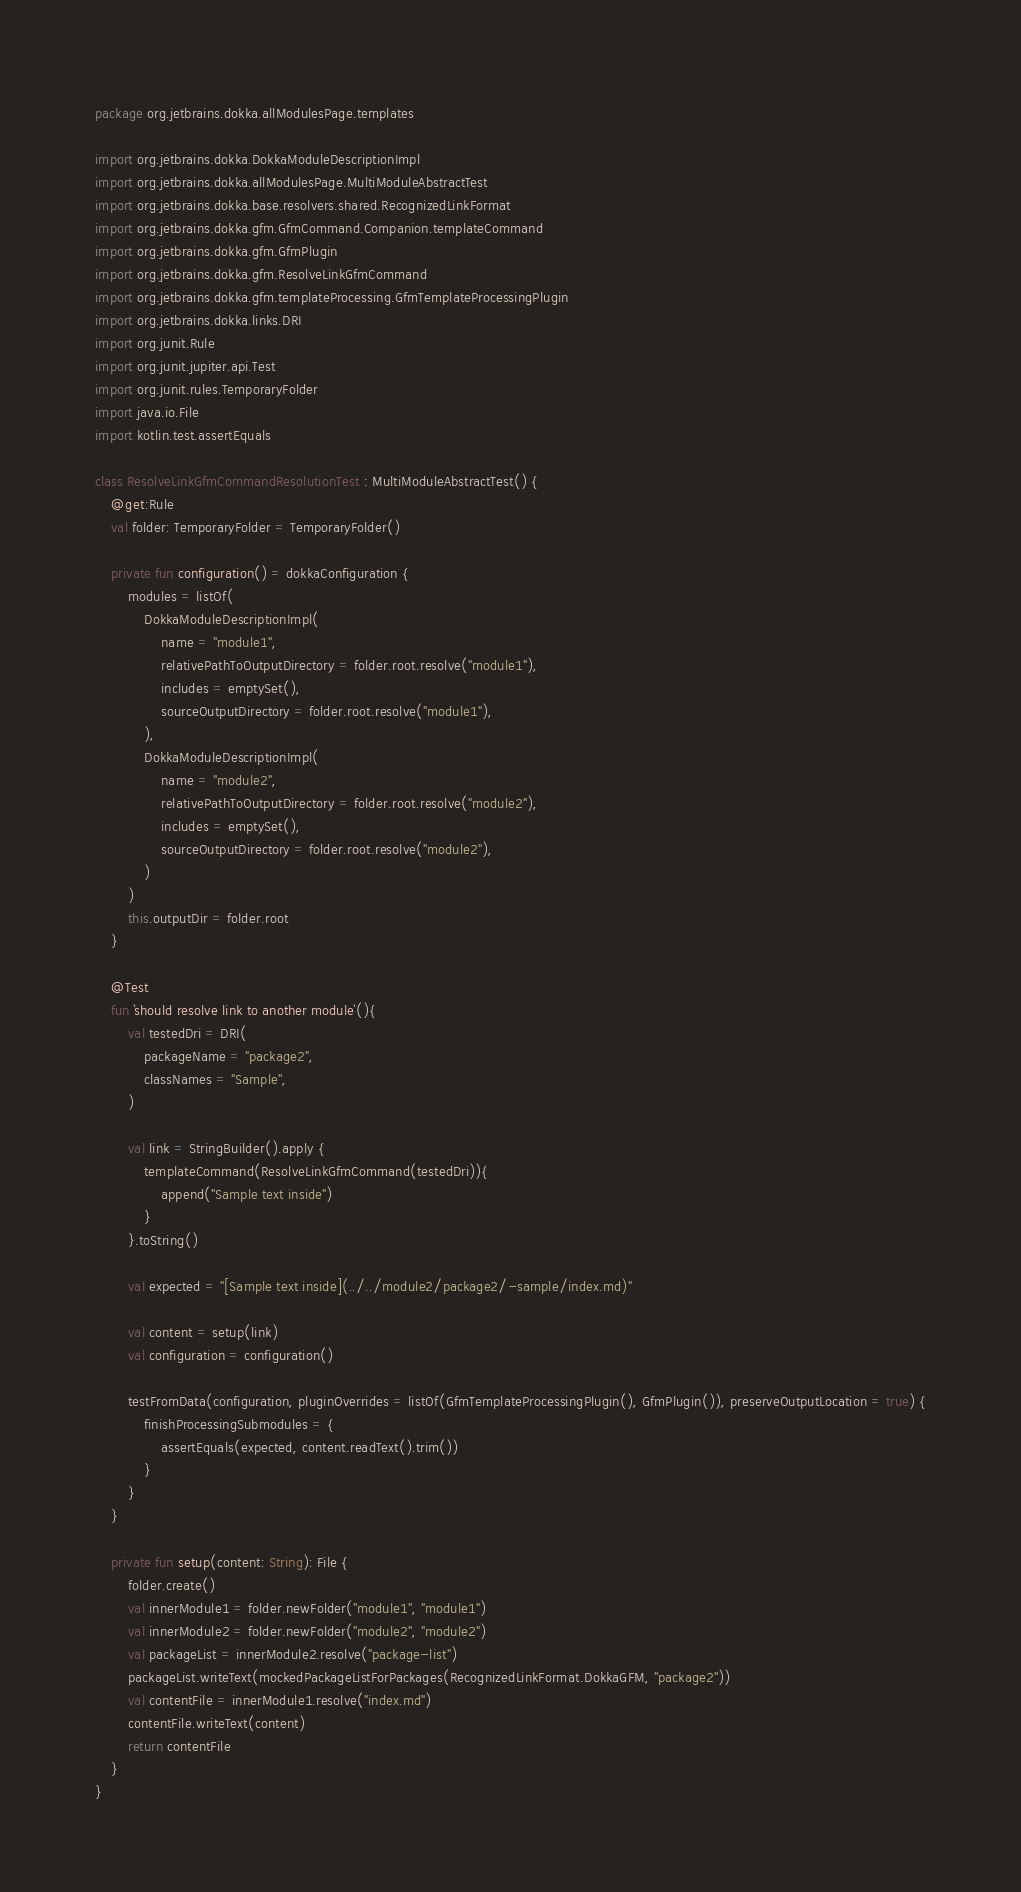<code> <loc_0><loc_0><loc_500><loc_500><_Kotlin_>package org.jetbrains.dokka.allModulesPage.templates

import org.jetbrains.dokka.DokkaModuleDescriptionImpl
import org.jetbrains.dokka.allModulesPage.MultiModuleAbstractTest
import org.jetbrains.dokka.base.resolvers.shared.RecognizedLinkFormat
import org.jetbrains.dokka.gfm.GfmCommand.Companion.templateCommand
import org.jetbrains.dokka.gfm.GfmPlugin
import org.jetbrains.dokka.gfm.ResolveLinkGfmCommand
import org.jetbrains.dokka.gfm.templateProcessing.GfmTemplateProcessingPlugin
import org.jetbrains.dokka.links.DRI
import org.junit.Rule
import org.junit.jupiter.api.Test
import org.junit.rules.TemporaryFolder
import java.io.File
import kotlin.test.assertEquals

class ResolveLinkGfmCommandResolutionTest : MultiModuleAbstractTest() {
    @get:Rule
    val folder: TemporaryFolder = TemporaryFolder()

    private fun configuration() = dokkaConfiguration {
        modules = listOf(
            DokkaModuleDescriptionImpl(
                name = "module1",
                relativePathToOutputDirectory = folder.root.resolve("module1"),
                includes = emptySet(),
                sourceOutputDirectory = folder.root.resolve("module1"),
            ),
            DokkaModuleDescriptionImpl(
                name = "module2",
                relativePathToOutputDirectory = folder.root.resolve("module2"),
                includes = emptySet(),
                sourceOutputDirectory = folder.root.resolve("module2"),
            )
        )
        this.outputDir = folder.root
    }

    @Test
    fun `should resolve link to another module`(){
        val testedDri = DRI(
            packageName = "package2",
            classNames = "Sample",
        )

        val link = StringBuilder().apply {
            templateCommand(ResolveLinkGfmCommand(testedDri)){
                append("Sample text inside")
            }
        }.toString()

        val expected = "[Sample text inside](../../module2/package2/-sample/index.md)"

        val content = setup(link)
        val configuration = configuration()

        testFromData(configuration, pluginOverrides = listOf(GfmTemplateProcessingPlugin(), GfmPlugin()), preserveOutputLocation = true) {
            finishProcessingSubmodules = {
                assertEquals(expected, content.readText().trim())
            }
        }
    }

    private fun setup(content: String): File {
        folder.create()
        val innerModule1 = folder.newFolder("module1", "module1")
        val innerModule2 = folder.newFolder("module2", "module2")
        val packageList = innerModule2.resolve("package-list")
        packageList.writeText(mockedPackageListForPackages(RecognizedLinkFormat.DokkaGFM, "package2"))
        val contentFile = innerModule1.resolve("index.md")
        contentFile.writeText(content)
        return contentFile
    }
}
</code> 